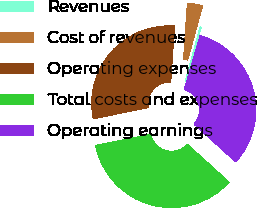Convert chart to OTSL. <chart><loc_0><loc_0><loc_500><loc_500><pie_chart><fcel>Revenues<fcel>Cost of revenues<fcel>Operating expenses<fcel>Total costs and expenses<fcel>Operating earnings<nl><fcel>0.26%<fcel>3.2%<fcel>29.25%<fcel>35.12%<fcel>32.18%<nl></chart> 